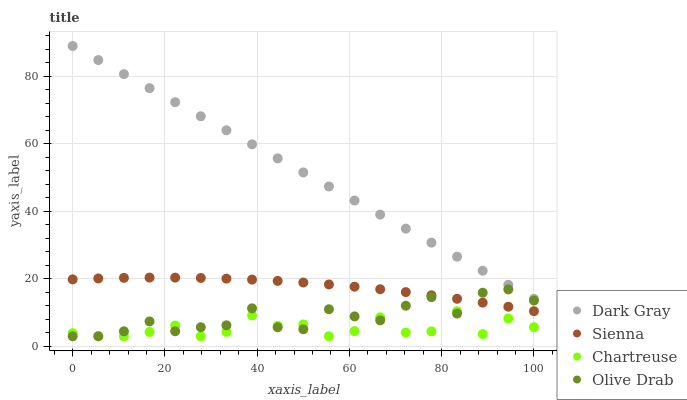Does Chartreuse have the minimum area under the curve?
Answer yes or no. Yes. Does Dark Gray have the maximum area under the curve?
Answer yes or no. Yes. Does Sienna have the minimum area under the curve?
Answer yes or no. No. Does Sienna have the maximum area under the curve?
Answer yes or no. No. Is Dark Gray the smoothest?
Answer yes or no. Yes. Is Chartreuse the roughest?
Answer yes or no. Yes. Is Sienna the smoothest?
Answer yes or no. No. Is Sienna the roughest?
Answer yes or no. No. Does Chartreuse have the lowest value?
Answer yes or no. Yes. Does Sienna have the lowest value?
Answer yes or no. No. Does Dark Gray have the highest value?
Answer yes or no. Yes. Does Sienna have the highest value?
Answer yes or no. No. Is Chartreuse less than Sienna?
Answer yes or no. Yes. Is Sienna greater than Chartreuse?
Answer yes or no. Yes. Does Sienna intersect Olive Drab?
Answer yes or no. Yes. Is Sienna less than Olive Drab?
Answer yes or no. No. Is Sienna greater than Olive Drab?
Answer yes or no. No. Does Chartreuse intersect Sienna?
Answer yes or no. No. 